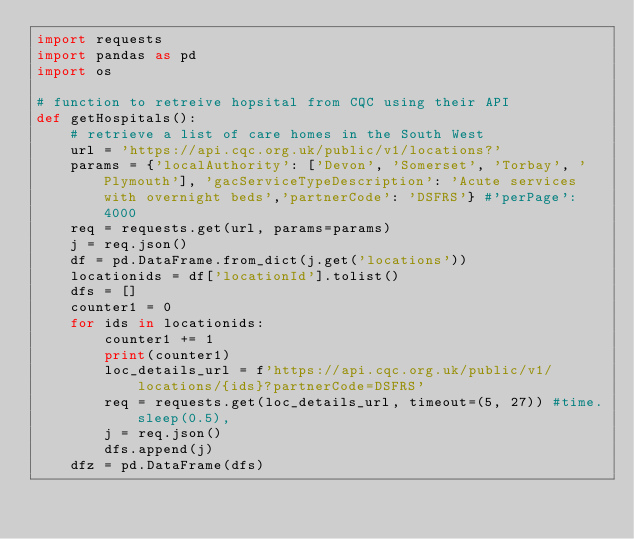<code> <loc_0><loc_0><loc_500><loc_500><_Python_>import requests
import pandas as pd
import os

# function to retreive hopsital from CQC using their API
def getHospitals():
    # retrieve a list of care homes in the South West
    url = 'https://api.cqc.org.uk/public/v1/locations?'
    params = {'localAuthority': ['Devon', 'Somerset', 'Torbay', 'Plymouth'], 'gacServiceTypeDescription': 'Acute services with overnight beds','partnerCode': 'DSFRS'} #'perPage': 4000
    req = requests.get(url, params=params)
    j = req.json()
    df = pd.DataFrame.from_dict(j.get('locations'))
    locationids = df['locationId'].tolist()
    dfs = []
    counter1 = 0
    for ids in locationids:
        counter1 += 1
        print(counter1)
        loc_details_url = f'https://api.cqc.org.uk/public/v1/locations/{ids}?partnerCode=DSFRS'
        req = requests.get(loc_details_url, timeout=(5, 27)) #time.sleep(0.5),
        j = req.json()
        dfs.append(j)
    dfz = pd.DataFrame(dfs)</code> 